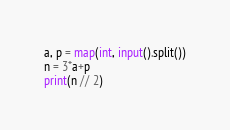Convert code to text. <code><loc_0><loc_0><loc_500><loc_500><_Python_>a, p = map(int, input().split())
n = 3*a+p
print(n // 2)</code> 